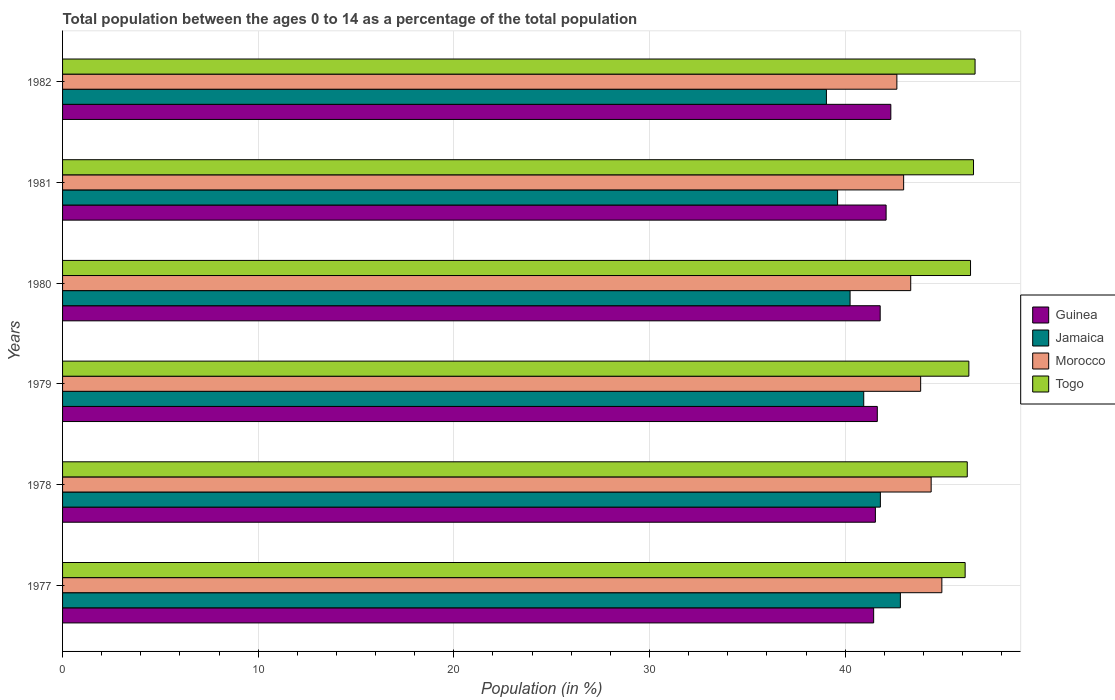How many different coloured bars are there?
Offer a very short reply. 4. How many bars are there on the 1st tick from the top?
Your answer should be very brief. 4. How many bars are there on the 6th tick from the bottom?
Offer a very short reply. 4. What is the percentage of the population ages 0 to 14 in Togo in 1979?
Make the answer very short. 46.32. Across all years, what is the maximum percentage of the population ages 0 to 14 in Morocco?
Ensure brevity in your answer.  44.94. Across all years, what is the minimum percentage of the population ages 0 to 14 in Morocco?
Offer a very short reply. 42.64. In which year was the percentage of the population ages 0 to 14 in Jamaica maximum?
Give a very brief answer. 1977. In which year was the percentage of the population ages 0 to 14 in Morocco minimum?
Provide a succinct answer. 1982. What is the total percentage of the population ages 0 to 14 in Guinea in the graph?
Your answer should be very brief. 250.86. What is the difference between the percentage of the population ages 0 to 14 in Jamaica in 1978 and that in 1980?
Provide a succinct answer. 1.55. What is the difference between the percentage of the population ages 0 to 14 in Guinea in 1979 and the percentage of the population ages 0 to 14 in Togo in 1977?
Offer a terse response. -4.49. What is the average percentage of the population ages 0 to 14 in Jamaica per year?
Ensure brevity in your answer.  40.75. In the year 1978, what is the difference between the percentage of the population ages 0 to 14 in Morocco and percentage of the population ages 0 to 14 in Jamaica?
Provide a succinct answer. 2.6. What is the ratio of the percentage of the population ages 0 to 14 in Togo in 1979 to that in 1981?
Your answer should be very brief. 0.99. What is the difference between the highest and the second highest percentage of the population ages 0 to 14 in Guinea?
Offer a terse response. 0.24. What is the difference between the highest and the lowest percentage of the population ages 0 to 14 in Guinea?
Your response must be concise. 0.88. What does the 2nd bar from the top in 1977 represents?
Ensure brevity in your answer.  Morocco. What does the 4th bar from the bottom in 1977 represents?
Provide a succinct answer. Togo. Are all the bars in the graph horizontal?
Keep it short and to the point. Yes. What is the difference between two consecutive major ticks on the X-axis?
Offer a terse response. 10. Are the values on the major ticks of X-axis written in scientific E-notation?
Provide a short and direct response. No. Does the graph contain any zero values?
Provide a short and direct response. No. Does the graph contain grids?
Provide a succinct answer. Yes. Where does the legend appear in the graph?
Your answer should be compact. Center right. What is the title of the graph?
Your answer should be compact. Total population between the ages 0 to 14 as a percentage of the total population. Does "France" appear as one of the legend labels in the graph?
Provide a short and direct response. No. What is the label or title of the Y-axis?
Provide a succinct answer. Years. What is the Population (in %) in Guinea in 1977?
Offer a terse response. 41.46. What is the Population (in %) in Jamaica in 1977?
Ensure brevity in your answer.  42.82. What is the Population (in %) of Morocco in 1977?
Keep it short and to the point. 44.94. What is the Population (in %) of Togo in 1977?
Your response must be concise. 46.13. What is the Population (in %) of Guinea in 1978?
Provide a succinct answer. 41.55. What is the Population (in %) of Jamaica in 1978?
Give a very brief answer. 41.8. What is the Population (in %) in Morocco in 1978?
Your answer should be compact. 44.4. What is the Population (in %) in Togo in 1978?
Make the answer very short. 46.24. What is the Population (in %) in Guinea in 1979?
Your response must be concise. 41.64. What is the Population (in %) in Jamaica in 1979?
Your answer should be compact. 40.95. What is the Population (in %) of Morocco in 1979?
Your answer should be compact. 43.86. What is the Population (in %) in Togo in 1979?
Provide a succinct answer. 46.32. What is the Population (in %) of Guinea in 1980?
Keep it short and to the point. 41.79. What is the Population (in %) of Jamaica in 1980?
Offer a terse response. 40.25. What is the Population (in %) of Morocco in 1980?
Offer a very short reply. 43.35. What is the Population (in %) of Togo in 1980?
Provide a succinct answer. 46.41. What is the Population (in %) in Guinea in 1981?
Give a very brief answer. 42.09. What is the Population (in %) of Jamaica in 1981?
Make the answer very short. 39.61. What is the Population (in %) in Morocco in 1981?
Ensure brevity in your answer.  42.99. What is the Population (in %) of Togo in 1981?
Your response must be concise. 46.56. What is the Population (in %) in Guinea in 1982?
Provide a succinct answer. 42.33. What is the Population (in %) in Jamaica in 1982?
Your response must be concise. 39.04. What is the Population (in %) in Morocco in 1982?
Ensure brevity in your answer.  42.64. What is the Population (in %) of Togo in 1982?
Provide a short and direct response. 46.64. Across all years, what is the maximum Population (in %) in Guinea?
Ensure brevity in your answer.  42.33. Across all years, what is the maximum Population (in %) in Jamaica?
Give a very brief answer. 42.82. Across all years, what is the maximum Population (in %) in Morocco?
Your response must be concise. 44.94. Across all years, what is the maximum Population (in %) in Togo?
Your answer should be compact. 46.64. Across all years, what is the minimum Population (in %) of Guinea?
Your response must be concise. 41.46. Across all years, what is the minimum Population (in %) of Jamaica?
Make the answer very short. 39.04. Across all years, what is the minimum Population (in %) of Morocco?
Keep it short and to the point. 42.64. Across all years, what is the minimum Population (in %) of Togo?
Provide a short and direct response. 46.13. What is the total Population (in %) of Guinea in the graph?
Offer a terse response. 250.86. What is the total Population (in %) in Jamaica in the graph?
Offer a terse response. 244.48. What is the total Population (in %) of Morocco in the graph?
Give a very brief answer. 262.18. What is the total Population (in %) in Togo in the graph?
Make the answer very short. 278.3. What is the difference between the Population (in %) in Guinea in 1977 and that in 1978?
Your answer should be very brief. -0.09. What is the difference between the Population (in %) of Jamaica in 1977 and that in 1978?
Your response must be concise. 1.02. What is the difference between the Population (in %) in Morocco in 1977 and that in 1978?
Keep it short and to the point. 0.55. What is the difference between the Population (in %) of Togo in 1977 and that in 1978?
Ensure brevity in your answer.  -0.11. What is the difference between the Population (in %) in Guinea in 1977 and that in 1979?
Offer a terse response. -0.19. What is the difference between the Population (in %) in Jamaica in 1977 and that in 1979?
Offer a very short reply. 1.87. What is the difference between the Population (in %) in Morocco in 1977 and that in 1979?
Provide a succinct answer. 1.08. What is the difference between the Population (in %) of Togo in 1977 and that in 1979?
Your answer should be very brief. -0.19. What is the difference between the Population (in %) in Guinea in 1977 and that in 1980?
Keep it short and to the point. -0.33. What is the difference between the Population (in %) of Jamaica in 1977 and that in 1980?
Your answer should be very brief. 2.57. What is the difference between the Population (in %) of Morocco in 1977 and that in 1980?
Offer a very short reply. 1.59. What is the difference between the Population (in %) in Togo in 1977 and that in 1980?
Your answer should be very brief. -0.28. What is the difference between the Population (in %) of Guinea in 1977 and that in 1981?
Offer a very short reply. -0.64. What is the difference between the Population (in %) in Jamaica in 1977 and that in 1981?
Keep it short and to the point. 3.21. What is the difference between the Population (in %) of Morocco in 1977 and that in 1981?
Give a very brief answer. 1.95. What is the difference between the Population (in %) in Togo in 1977 and that in 1981?
Make the answer very short. -0.43. What is the difference between the Population (in %) of Guinea in 1977 and that in 1982?
Your response must be concise. -0.88. What is the difference between the Population (in %) of Jamaica in 1977 and that in 1982?
Your response must be concise. 3.78. What is the difference between the Population (in %) in Morocco in 1977 and that in 1982?
Make the answer very short. 2.3. What is the difference between the Population (in %) in Togo in 1977 and that in 1982?
Keep it short and to the point. -0.51. What is the difference between the Population (in %) in Guinea in 1978 and that in 1979?
Make the answer very short. -0.1. What is the difference between the Population (in %) in Jamaica in 1978 and that in 1979?
Provide a short and direct response. 0.85. What is the difference between the Population (in %) in Morocco in 1978 and that in 1979?
Offer a very short reply. 0.54. What is the difference between the Population (in %) in Togo in 1978 and that in 1979?
Offer a terse response. -0.08. What is the difference between the Population (in %) in Guinea in 1978 and that in 1980?
Ensure brevity in your answer.  -0.25. What is the difference between the Population (in %) of Jamaica in 1978 and that in 1980?
Provide a short and direct response. 1.55. What is the difference between the Population (in %) of Morocco in 1978 and that in 1980?
Your answer should be compact. 1.05. What is the difference between the Population (in %) in Togo in 1978 and that in 1980?
Ensure brevity in your answer.  -0.17. What is the difference between the Population (in %) of Guinea in 1978 and that in 1981?
Provide a succinct answer. -0.55. What is the difference between the Population (in %) of Jamaica in 1978 and that in 1981?
Your response must be concise. 2.19. What is the difference between the Population (in %) of Morocco in 1978 and that in 1981?
Offer a very short reply. 1.41. What is the difference between the Population (in %) of Togo in 1978 and that in 1981?
Offer a very short reply. -0.32. What is the difference between the Population (in %) in Guinea in 1978 and that in 1982?
Your answer should be compact. -0.79. What is the difference between the Population (in %) in Jamaica in 1978 and that in 1982?
Keep it short and to the point. 2.76. What is the difference between the Population (in %) of Morocco in 1978 and that in 1982?
Offer a very short reply. 1.75. What is the difference between the Population (in %) of Togo in 1978 and that in 1982?
Ensure brevity in your answer.  -0.4. What is the difference between the Population (in %) in Guinea in 1979 and that in 1980?
Provide a short and direct response. -0.15. What is the difference between the Population (in %) of Jamaica in 1979 and that in 1980?
Your response must be concise. 0.7. What is the difference between the Population (in %) of Morocco in 1979 and that in 1980?
Offer a very short reply. 0.51. What is the difference between the Population (in %) of Togo in 1979 and that in 1980?
Keep it short and to the point. -0.09. What is the difference between the Population (in %) in Guinea in 1979 and that in 1981?
Offer a very short reply. -0.45. What is the difference between the Population (in %) of Jamaica in 1979 and that in 1981?
Your response must be concise. 1.34. What is the difference between the Population (in %) in Morocco in 1979 and that in 1981?
Give a very brief answer. 0.87. What is the difference between the Population (in %) of Togo in 1979 and that in 1981?
Keep it short and to the point. -0.24. What is the difference between the Population (in %) in Guinea in 1979 and that in 1982?
Keep it short and to the point. -0.69. What is the difference between the Population (in %) in Jamaica in 1979 and that in 1982?
Your answer should be compact. 1.91. What is the difference between the Population (in %) of Morocco in 1979 and that in 1982?
Your answer should be very brief. 1.22. What is the difference between the Population (in %) in Togo in 1979 and that in 1982?
Give a very brief answer. -0.32. What is the difference between the Population (in %) of Guinea in 1980 and that in 1981?
Offer a terse response. -0.3. What is the difference between the Population (in %) in Jamaica in 1980 and that in 1981?
Give a very brief answer. 0.64. What is the difference between the Population (in %) of Morocco in 1980 and that in 1981?
Give a very brief answer. 0.36. What is the difference between the Population (in %) in Togo in 1980 and that in 1981?
Make the answer very short. -0.15. What is the difference between the Population (in %) of Guinea in 1980 and that in 1982?
Give a very brief answer. -0.54. What is the difference between the Population (in %) in Jamaica in 1980 and that in 1982?
Make the answer very short. 1.21. What is the difference between the Population (in %) in Morocco in 1980 and that in 1982?
Your response must be concise. 0.71. What is the difference between the Population (in %) of Togo in 1980 and that in 1982?
Give a very brief answer. -0.23. What is the difference between the Population (in %) in Guinea in 1981 and that in 1982?
Make the answer very short. -0.24. What is the difference between the Population (in %) in Jamaica in 1981 and that in 1982?
Your answer should be compact. 0.57. What is the difference between the Population (in %) of Morocco in 1981 and that in 1982?
Keep it short and to the point. 0.35. What is the difference between the Population (in %) of Togo in 1981 and that in 1982?
Your answer should be compact. -0.08. What is the difference between the Population (in %) of Guinea in 1977 and the Population (in %) of Jamaica in 1978?
Your answer should be very brief. -0.34. What is the difference between the Population (in %) in Guinea in 1977 and the Population (in %) in Morocco in 1978?
Give a very brief answer. -2.94. What is the difference between the Population (in %) in Guinea in 1977 and the Population (in %) in Togo in 1978?
Offer a terse response. -4.78. What is the difference between the Population (in %) in Jamaica in 1977 and the Population (in %) in Morocco in 1978?
Give a very brief answer. -1.57. What is the difference between the Population (in %) of Jamaica in 1977 and the Population (in %) of Togo in 1978?
Give a very brief answer. -3.42. What is the difference between the Population (in %) of Morocco in 1977 and the Population (in %) of Togo in 1978?
Provide a short and direct response. -1.3. What is the difference between the Population (in %) in Guinea in 1977 and the Population (in %) in Jamaica in 1979?
Your answer should be very brief. 0.51. What is the difference between the Population (in %) of Guinea in 1977 and the Population (in %) of Morocco in 1979?
Offer a very short reply. -2.4. What is the difference between the Population (in %) in Guinea in 1977 and the Population (in %) in Togo in 1979?
Your answer should be very brief. -4.87. What is the difference between the Population (in %) of Jamaica in 1977 and the Population (in %) of Morocco in 1979?
Provide a succinct answer. -1.04. What is the difference between the Population (in %) in Jamaica in 1977 and the Population (in %) in Togo in 1979?
Keep it short and to the point. -3.5. What is the difference between the Population (in %) of Morocco in 1977 and the Population (in %) of Togo in 1979?
Provide a succinct answer. -1.38. What is the difference between the Population (in %) of Guinea in 1977 and the Population (in %) of Jamaica in 1980?
Your response must be concise. 1.21. What is the difference between the Population (in %) in Guinea in 1977 and the Population (in %) in Morocco in 1980?
Your answer should be compact. -1.89. What is the difference between the Population (in %) in Guinea in 1977 and the Population (in %) in Togo in 1980?
Provide a short and direct response. -4.95. What is the difference between the Population (in %) in Jamaica in 1977 and the Population (in %) in Morocco in 1980?
Give a very brief answer. -0.53. What is the difference between the Population (in %) of Jamaica in 1977 and the Population (in %) of Togo in 1980?
Your response must be concise. -3.59. What is the difference between the Population (in %) of Morocco in 1977 and the Population (in %) of Togo in 1980?
Provide a short and direct response. -1.47. What is the difference between the Population (in %) in Guinea in 1977 and the Population (in %) in Jamaica in 1981?
Give a very brief answer. 1.84. What is the difference between the Population (in %) of Guinea in 1977 and the Population (in %) of Morocco in 1981?
Make the answer very short. -1.53. What is the difference between the Population (in %) of Guinea in 1977 and the Population (in %) of Togo in 1981?
Keep it short and to the point. -5.1. What is the difference between the Population (in %) of Jamaica in 1977 and the Population (in %) of Morocco in 1981?
Ensure brevity in your answer.  -0.17. What is the difference between the Population (in %) of Jamaica in 1977 and the Population (in %) of Togo in 1981?
Offer a terse response. -3.74. What is the difference between the Population (in %) in Morocco in 1977 and the Population (in %) in Togo in 1981?
Make the answer very short. -1.62. What is the difference between the Population (in %) of Guinea in 1977 and the Population (in %) of Jamaica in 1982?
Ensure brevity in your answer.  2.41. What is the difference between the Population (in %) in Guinea in 1977 and the Population (in %) in Morocco in 1982?
Provide a short and direct response. -1.19. What is the difference between the Population (in %) in Guinea in 1977 and the Population (in %) in Togo in 1982?
Ensure brevity in your answer.  -5.18. What is the difference between the Population (in %) of Jamaica in 1977 and the Population (in %) of Morocco in 1982?
Provide a succinct answer. 0.18. What is the difference between the Population (in %) in Jamaica in 1977 and the Population (in %) in Togo in 1982?
Provide a succinct answer. -3.82. What is the difference between the Population (in %) in Morocco in 1977 and the Population (in %) in Togo in 1982?
Ensure brevity in your answer.  -1.7. What is the difference between the Population (in %) in Guinea in 1978 and the Population (in %) in Jamaica in 1979?
Your answer should be compact. 0.6. What is the difference between the Population (in %) of Guinea in 1978 and the Population (in %) of Morocco in 1979?
Your answer should be compact. -2.31. What is the difference between the Population (in %) in Guinea in 1978 and the Population (in %) in Togo in 1979?
Provide a short and direct response. -4.78. What is the difference between the Population (in %) of Jamaica in 1978 and the Population (in %) of Morocco in 1979?
Offer a very short reply. -2.06. What is the difference between the Population (in %) in Jamaica in 1978 and the Population (in %) in Togo in 1979?
Provide a short and direct response. -4.52. What is the difference between the Population (in %) in Morocco in 1978 and the Population (in %) in Togo in 1979?
Provide a succinct answer. -1.93. What is the difference between the Population (in %) in Guinea in 1978 and the Population (in %) in Jamaica in 1980?
Keep it short and to the point. 1.29. What is the difference between the Population (in %) in Guinea in 1978 and the Population (in %) in Morocco in 1980?
Provide a short and direct response. -1.81. What is the difference between the Population (in %) in Guinea in 1978 and the Population (in %) in Togo in 1980?
Offer a very short reply. -4.86. What is the difference between the Population (in %) in Jamaica in 1978 and the Population (in %) in Morocco in 1980?
Your answer should be very brief. -1.55. What is the difference between the Population (in %) in Jamaica in 1978 and the Population (in %) in Togo in 1980?
Offer a terse response. -4.61. What is the difference between the Population (in %) in Morocco in 1978 and the Population (in %) in Togo in 1980?
Offer a terse response. -2.01. What is the difference between the Population (in %) in Guinea in 1978 and the Population (in %) in Jamaica in 1981?
Your response must be concise. 1.93. What is the difference between the Population (in %) of Guinea in 1978 and the Population (in %) of Morocco in 1981?
Offer a very short reply. -1.44. What is the difference between the Population (in %) in Guinea in 1978 and the Population (in %) in Togo in 1981?
Your answer should be compact. -5.02. What is the difference between the Population (in %) of Jamaica in 1978 and the Population (in %) of Morocco in 1981?
Ensure brevity in your answer.  -1.19. What is the difference between the Population (in %) in Jamaica in 1978 and the Population (in %) in Togo in 1981?
Your response must be concise. -4.76. What is the difference between the Population (in %) of Morocco in 1978 and the Population (in %) of Togo in 1981?
Your answer should be very brief. -2.16. What is the difference between the Population (in %) of Guinea in 1978 and the Population (in %) of Jamaica in 1982?
Ensure brevity in your answer.  2.5. What is the difference between the Population (in %) of Guinea in 1978 and the Population (in %) of Morocco in 1982?
Ensure brevity in your answer.  -1.1. What is the difference between the Population (in %) of Guinea in 1978 and the Population (in %) of Togo in 1982?
Your response must be concise. -5.09. What is the difference between the Population (in %) of Jamaica in 1978 and the Population (in %) of Morocco in 1982?
Provide a succinct answer. -0.84. What is the difference between the Population (in %) of Jamaica in 1978 and the Population (in %) of Togo in 1982?
Offer a terse response. -4.84. What is the difference between the Population (in %) in Morocco in 1978 and the Population (in %) in Togo in 1982?
Provide a succinct answer. -2.24. What is the difference between the Population (in %) in Guinea in 1979 and the Population (in %) in Jamaica in 1980?
Provide a succinct answer. 1.39. What is the difference between the Population (in %) of Guinea in 1979 and the Population (in %) of Morocco in 1980?
Offer a terse response. -1.71. What is the difference between the Population (in %) in Guinea in 1979 and the Population (in %) in Togo in 1980?
Provide a short and direct response. -4.77. What is the difference between the Population (in %) of Jamaica in 1979 and the Population (in %) of Morocco in 1980?
Your response must be concise. -2.4. What is the difference between the Population (in %) in Jamaica in 1979 and the Population (in %) in Togo in 1980?
Provide a short and direct response. -5.46. What is the difference between the Population (in %) in Morocco in 1979 and the Population (in %) in Togo in 1980?
Offer a terse response. -2.55. What is the difference between the Population (in %) in Guinea in 1979 and the Population (in %) in Jamaica in 1981?
Your answer should be compact. 2.03. What is the difference between the Population (in %) in Guinea in 1979 and the Population (in %) in Morocco in 1981?
Your response must be concise. -1.35. What is the difference between the Population (in %) in Guinea in 1979 and the Population (in %) in Togo in 1981?
Your answer should be very brief. -4.92. What is the difference between the Population (in %) in Jamaica in 1979 and the Population (in %) in Morocco in 1981?
Offer a terse response. -2.04. What is the difference between the Population (in %) in Jamaica in 1979 and the Population (in %) in Togo in 1981?
Keep it short and to the point. -5.61. What is the difference between the Population (in %) of Morocco in 1979 and the Population (in %) of Togo in 1981?
Give a very brief answer. -2.7. What is the difference between the Population (in %) of Guinea in 1979 and the Population (in %) of Jamaica in 1982?
Provide a succinct answer. 2.6. What is the difference between the Population (in %) of Guinea in 1979 and the Population (in %) of Morocco in 1982?
Keep it short and to the point. -1. What is the difference between the Population (in %) of Guinea in 1979 and the Population (in %) of Togo in 1982?
Ensure brevity in your answer.  -5. What is the difference between the Population (in %) in Jamaica in 1979 and the Population (in %) in Morocco in 1982?
Give a very brief answer. -1.69. What is the difference between the Population (in %) in Jamaica in 1979 and the Population (in %) in Togo in 1982?
Offer a terse response. -5.69. What is the difference between the Population (in %) in Morocco in 1979 and the Population (in %) in Togo in 1982?
Make the answer very short. -2.78. What is the difference between the Population (in %) in Guinea in 1980 and the Population (in %) in Jamaica in 1981?
Keep it short and to the point. 2.18. What is the difference between the Population (in %) in Guinea in 1980 and the Population (in %) in Morocco in 1981?
Keep it short and to the point. -1.2. What is the difference between the Population (in %) of Guinea in 1980 and the Population (in %) of Togo in 1981?
Keep it short and to the point. -4.77. What is the difference between the Population (in %) of Jamaica in 1980 and the Population (in %) of Morocco in 1981?
Your answer should be compact. -2.74. What is the difference between the Population (in %) in Jamaica in 1980 and the Population (in %) in Togo in 1981?
Your answer should be compact. -6.31. What is the difference between the Population (in %) of Morocco in 1980 and the Population (in %) of Togo in 1981?
Offer a very short reply. -3.21. What is the difference between the Population (in %) in Guinea in 1980 and the Population (in %) in Jamaica in 1982?
Provide a succinct answer. 2.75. What is the difference between the Population (in %) of Guinea in 1980 and the Population (in %) of Morocco in 1982?
Make the answer very short. -0.85. What is the difference between the Population (in %) in Guinea in 1980 and the Population (in %) in Togo in 1982?
Your response must be concise. -4.85. What is the difference between the Population (in %) in Jamaica in 1980 and the Population (in %) in Morocco in 1982?
Offer a very short reply. -2.39. What is the difference between the Population (in %) in Jamaica in 1980 and the Population (in %) in Togo in 1982?
Your answer should be compact. -6.39. What is the difference between the Population (in %) of Morocco in 1980 and the Population (in %) of Togo in 1982?
Provide a short and direct response. -3.29. What is the difference between the Population (in %) in Guinea in 1981 and the Population (in %) in Jamaica in 1982?
Your answer should be compact. 3.05. What is the difference between the Population (in %) in Guinea in 1981 and the Population (in %) in Morocco in 1982?
Your answer should be very brief. -0.55. What is the difference between the Population (in %) in Guinea in 1981 and the Population (in %) in Togo in 1982?
Provide a succinct answer. -4.55. What is the difference between the Population (in %) of Jamaica in 1981 and the Population (in %) of Morocco in 1982?
Offer a very short reply. -3.03. What is the difference between the Population (in %) in Jamaica in 1981 and the Population (in %) in Togo in 1982?
Give a very brief answer. -7.03. What is the difference between the Population (in %) of Morocco in 1981 and the Population (in %) of Togo in 1982?
Your response must be concise. -3.65. What is the average Population (in %) in Guinea per year?
Give a very brief answer. 41.81. What is the average Population (in %) in Jamaica per year?
Give a very brief answer. 40.75. What is the average Population (in %) in Morocco per year?
Offer a very short reply. 43.7. What is the average Population (in %) in Togo per year?
Provide a succinct answer. 46.38. In the year 1977, what is the difference between the Population (in %) in Guinea and Population (in %) in Jamaica?
Your answer should be very brief. -1.37. In the year 1977, what is the difference between the Population (in %) in Guinea and Population (in %) in Morocco?
Your response must be concise. -3.49. In the year 1977, what is the difference between the Population (in %) of Guinea and Population (in %) of Togo?
Offer a terse response. -4.68. In the year 1977, what is the difference between the Population (in %) in Jamaica and Population (in %) in Morocco?
Your response must be concise. -2.12. In the year 1977, what is the difference between the Population (in %) of Jamaica and Population (in %) of Togo?
Your answer should be very brief. -3.31. In the year 1977, what is the difference between the Population (in %) in Morocco and Population (in %) in Togo?
Provide a short and direct response. -1.19. In the year 1978, what is the difference between the Population (in %) in Guinea and Population (in %) in Jamaica?
Your answer should be compact. -0.26. In the year 1978, what is the difference between the Population (in %) in Guinea and Population (in %) in Morocco?
Make the answer very short. -2.85. In the year 1978, what is the difference between the Population (in %) of Guinea and Population (in %) of Togo?
Make the answer very short. -4.7. In the year 1978, what is the difference between the Population (in %) in Jamaica and Population (in %) in Morocco?
Your answer should be very brief. -2.6. In the year 1978, what is the difference between the Population (in %) in Jamaica and Population (in %) in Togo?
Your answer should be compact. -4.44. In the year 1978, what is the difference between the Population (in %) in Morocco and Population (in %) in Togo?
Make the answer very short. -1.85. In the year 1979, what is the difference between the Population (in %) of Guinea and Population (in %) of Jamaica?
Your answer should be very brief. 0.69. In the year 1979, what is the difference between the Population (in %) of Guinea and Population (in %) of Morocco?
Keep it short and to the point. -2.22. In the year 1979, what is the difference between the Population (in %) of Guinea and Population (in %) of Togo?
Offer a very short reply. -4.68. In the year 1979, what is the difference between the Population (in %) of Jamaica and Population (in %) of Morocco?
Offer a terse response. -2.91. In the year 1979, what is the difference between the Population (in %) in Jamaica and Population (in %) in Togo?
Your answer should be very brief. -5.37. In the year 1979, what is the difference between the Population (in %) of Morocco and Population (in %) of Togo?
Offer a very short reply. -2.46. In the year 1980, what is the difference between the Population (in %) of Guinea and Population (in %) of Jamaica?
Your answer should be very brief. 1.54. In the year 1980, what is the difference between the Population (in %) in Guinea and Population (in %) in Morocco?
Give a very brief answer. -1.56. In the year 1980, what is the difference between the Population (in %) in Guinea and Population (in %) in Togo?
Offer a terse response. -4.62. In the year 1980, what is the difference between the Population (in %) in Jamaica and Population (in %) in Morocco?
Offer a terse response. -3.1. In the year 1980, what is the difference between the Population (in %) in Jamaica and Population (in %) in Togo?
Offer a very short reply. -6.16. In the year 1980, what is the difference between the Population (in %) of Morocco and Population (in %) of Togo?
Give a very brief answer. -3.06. In the year 1981, what is the difference between the Population (in %) in Guinea and Population (in %) in Jamaica?
Ensure brevity in your answer.  2.48. In the year 1981, what is the difference between the Population (in %) in Guinea and Population (in %) in Morocco?
Provide a succinct answer. -0.9. In the year 1981, what is the difference between the Population (in %) in Guinea and Population (in %) in Togo?
Your answer should be very brief. -4.47. In the year 1981, what is the difference between the Population (in %) of Jamaica and Population (in %) of Morocco?
Your answer should be compact. -3.38. In the year 1981, what is the difference between the Population (in %) in Jamaica and Population (in %) in Togo?
Your response must be concise. -6.95. In the year 1981, what is the difference between the Population (in %) of Morocco and Population (in %) of Togo?
Ensure brevity in your answer.  -3.57. In the year 1982, what is the difference between the Population (in %) in Guinea and Population (in %) in Jamaica?
Your response must be concise. 3.29. In the year 1982, what is the difference between the Population (in %) of Guinea and Population (in %) of Morocco?
Keep it short and to the point. -0.31. In the year 1982, what is the difference between the Population (in %) of Guinea and Population (in %) of Togo?
Ensure brevity in your answer.  -4.3. In the year 1982, what is the difference between the Population (in %) in Jamaica and Population (in %) in Morocco?
Keep it short and to the point. -3.6. In the year 1982, what is the difference between the Population (in %) in Jamaica and Population (in %) in Togo?
Your answer should be compact. -7.6. In the year 1982, what is the difference between the Population (in %) of Morocco and Population (in %) of Togo?
Provide a succinct answer. -4. What is the ratio of the Population (in %) of Guinea in 1977 to that in 1978?
Keep it short and to the point. 1. What is the ratio of the Population (in %) of Jamaica in 1977 to that in 1978?
Your response must be concise. 1.02. What is the ratio of the Population (in %) in Morocco in 1977 to that in 1978?
Keep it short and to the point. 1.01. What is the ratio of the Population (in %) in Jamaica in 1977 to that in 1979?
Make the answer very short. 1.05. What is the ratio of the Population (in %) in Morocco in 1977 to that in 1979?
Provide a short and direct response. 1.02. What is the ratio of the Population (in %) of Guinea in 1977 to that in 1980?
Provide a short and direct response. 0.99. What is the ratio of the Population (in %) of Jamaica in 1977 to that in 1980?
Your answer should be compact. 1.06. What is the ratio of the Population (in %) in Morocco in 1977 to that in 1980?
Keep it short and to the point. 1.04. What is the ratio of the Population (in %) of Togo in 1977 to that in 1980?
Your answer should be compact. 0.99. What is the ratio of the Population (in %) in Guinea in 1977 to that in 1981?
Make the answer very short. 0.98. What is the ratio of the Population (in %) of Jamaica in 1977 to that in 1981?
Make the answer very short. 1.08. What is the ratio of the Population (in %) in Morocco in 1977 to that in 1981?
Your response must be concise. 1.05. What is the ratio of the Population (in %) of Togo in 1977 to that in 1981?
Keep it short and to the point. 0.99. What is the ratio of the Population (in %) of Guinea in 1977 to that in 1982?
Provide a succinct answer. 0.98. What is the ratio of the Population (in %) of Jamaica in 1977 to that in 1982?
Ensure brevity in your answer.  1.1. What is the ratio of the Population (in %) of Morocco in 1977 to that in 1982?
Your answer should be compact. 1.05. What is the ratio of the Population (in %) in Togo in 1977 to that in 1982?
Ensure brevity in your answer.  0.99. What is the ratio of the Population (in %) of Jamaica in 1978 to that in 1979?
Keep it short and to the point. 1.02. What is the ratio of the Population (in %) in Morocco in 1978 to that in 1979?
Make the answer very short. 1.01. What is the ratio of the Population (in %) in Togo in 1978 to that in 1979?
Offer a terse response. 1. What is the ratio of the Population (in %) of Morocco in 1978 to that in 1980?
Make the answer very short. 1.02. What is the ratio of the Population (in %) of Guinea in 1978 to that in 1981?
Make the answer very short. 0.99. What is the ratio of the Population (in %) in Jamaica in 1978 to that in 1981?
Provide a succinct answer. 1.06. What is the ratio of the Population (in %) of Morocco in 1978 to that in 1981?
Make the answer very short. 1.03. What is the ratio of the Population (in %) of Togo in 1978 to that in 1981?
Your answer should be very brief. 0.99. What is the ratio of the Population (in %) of Guinea in 1978 to that in 1982?
Your response must be concise. 0.98. What is the ratio of the Population (in %) in Jamaica in 1978 to that in 1982?
Your answer should be compact. 1.07. What is the ratio of the Population (in %) in Morocco in 1978 to that in 1982?
Your response must be concise. 1.04. What is the ratio of the Population (in %) in Jamaica in 1979 to that in 1980?
Give a very brief answer. 1.02. What is the ratio of the Population (in %) in Morocco in 1979 to that in 1980?
Make the answer very short. 1.01. What is the ratio of the Population (in %) in Guinea in 1979 to that in 1981?
Provide a short and direct response. 0.99. What is the ratio of the Population (in %) of Jamaica in 1979 to that in 1981?
Your response must be concise. 1.03. What is the ratio of the Population (in %) in Morocco in 1979 to that in 1981?
Provide a succinct answer. 1.02. What is the ratio of the Population (in %) of Guinea in 1979 to that in 1982?
Keep it short and to the point. 0.98. What is the ratio of the Population (in %) of Jamaica in 1979 to that in 1982?
Keep it short and to the point. 1.05. What is the ratio of the Population (in %) in Morocco in 1979 to that in 1982?
Make the answer very short. 1.03. What is the ratio of the Population (in %) of Jamaica in 1980 to that in 1981?
Your answer should be compact. 1.02. What is the ratio of the Population (in %) of Morocco in 1980 to that in 1981?
Provide a short and direct response. 1.01. What is the ratio of the Population (in %) of Togo in 1980 to that in 1981?
Your answer should be very brief. 1. What is the ratio of the Population (in %) of Guinea in 1980 to that in 1982?
Keep it short and to the point. 0.99. What is the ratio of the Population (in %) in Jamaica in 1980 to that in 1982?
Your response must be concise. 1.03. What is the ratio of the Population (in %) of Morocco in 1980 to that in 1982?
Offer a terse response. 1.02. What is the ratio of the Population (in %) of Jamaica in 1981 to that in 1982?
Your response must be concise. 1.01. What is the difference between the highest and the second highest Population (in %) of Guinea?
Give a very brief answer. 0.24. What is the difference between the highest and the second highest Population (in %) in Jamaica?
Keep it short and to the point. 1.02. What is the difference between the highest and the second highest Population (in %) of Morocco?
Provide a succinct answer. 0.55. What is the difference between the highest and the second highest Population (in %) of Togo?
Keep it short and to the point. 0.08. What is the difference between the highest and the lowest Population (in %) of Guinea?
Provide a short and direct response. 0.88. What is the difference between the highest and the lowest Population (in %) of Jamaica?
Keep it short and to the point. 3.78. What is the difference between the highest and the lowest Population (in %) in Morocco?
Make the answer very short. 2.3. What is the difference between the highest and the lowest Population (in %) in Togo?
Provide a short and direct response. 0.51. 